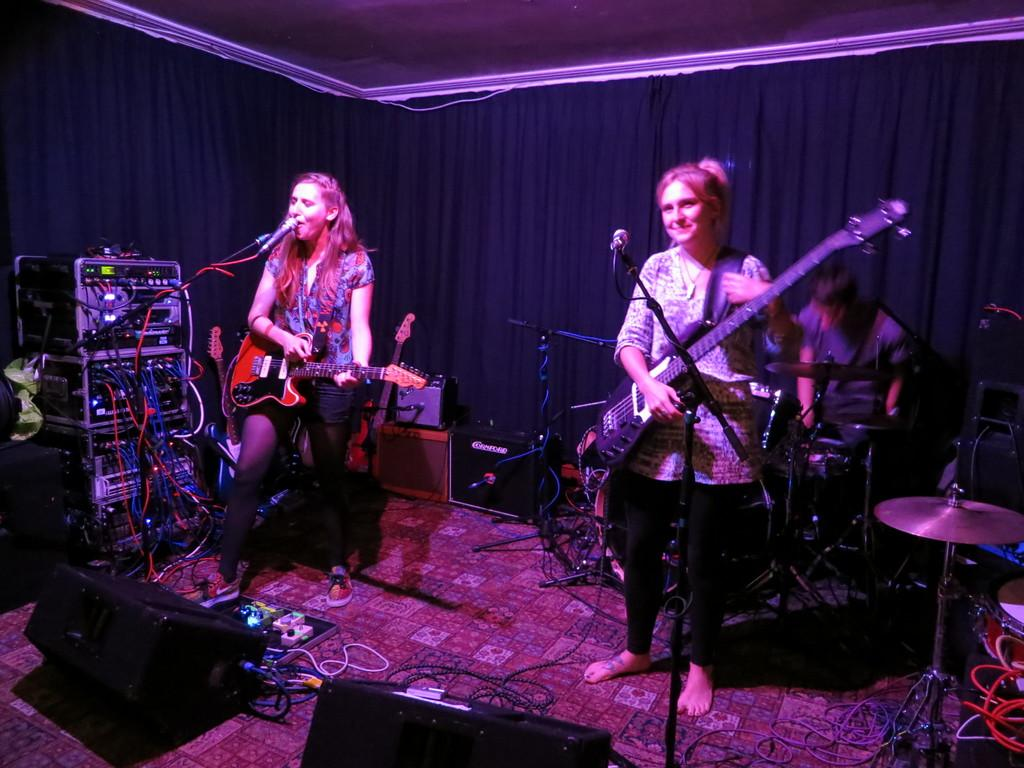How many people are present in the image? There are three people in the image. What are the two standing people doing? Both standing people are holding guitars in their hands. Can you describe the position of the third person? The information provided does not specify the position of the third person. What type of door can be seen in the background of the image? There is no door present in the image; it only features three people, two of whom are holding guitars. 